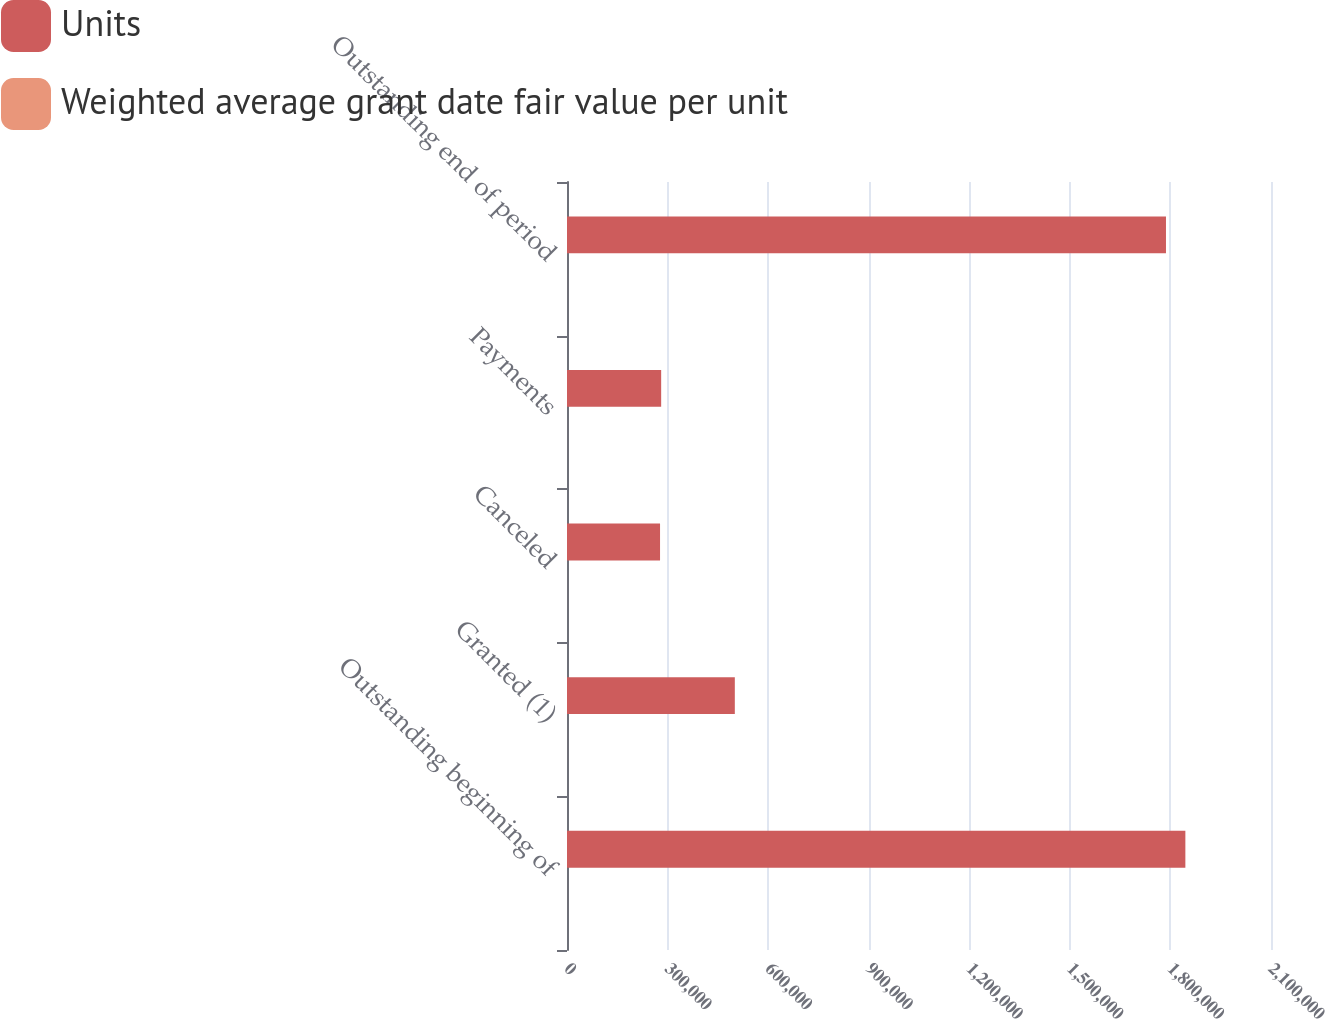Convert chart to OTSL. <chart><loc_0><loc_0><loc_500><loc_500><stacked_bar_chart><ecel><fcel>Outstanding beginning of<fcel>Granted (1)<fcel>Canceled<fcel>Payments<fcel>Outstanding end of period<nl><fcel>Units<fcel>1.84456e+06<fcel>500609<fcel>277546<fcel>280897<fcel>1.78673e+06<nl><fcel>Weighted average grant date fair value per unit<fcel>38.22<fcel>59.22<fcel>48.34<fcel>48.34<fcel>40.94<nl></chart> 